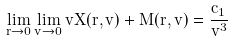Convert formula to latex. <formula><loc_0><loc_0><loc_500><loc_500>\lim _ { r \to 0 } \lim _ { v \to 0 } v X ( r , v ) + M ( r , v ) = \frac { c _ { 1 } } { v ^ { 3 } }</formula> 